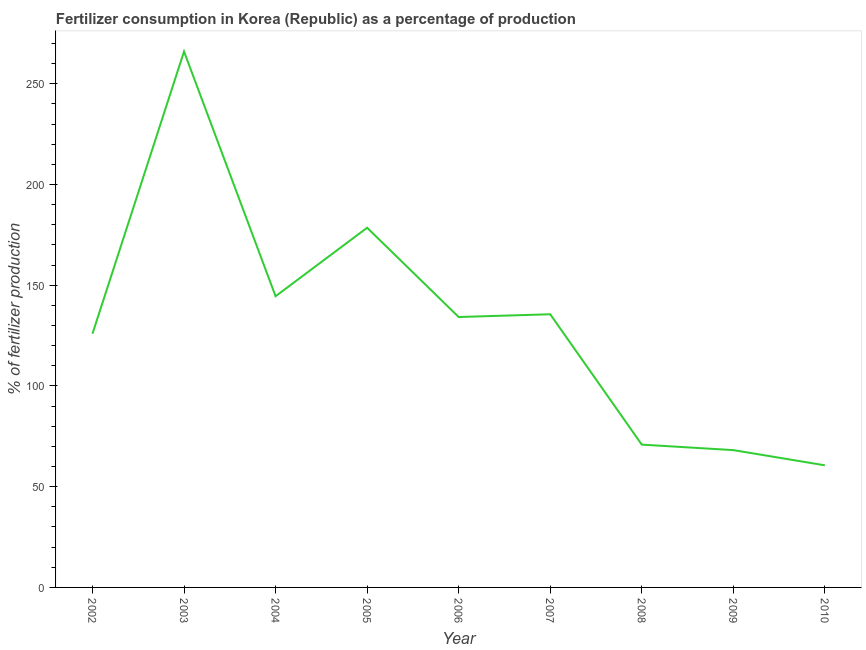What is the amount of fertilizer consumption in 2007?
Offer a terse response. 135.6. Across all years, what is the maximum amount of fertilizer consumption?
Offer a terse response. 266.02. Across all years, what is the minimum amount of fertilizer consumption?
Your answer should be compact. 60.61. What is the sum of the amount of fertilizer consumption?
Provide a succinct answer. 1184.54. What is the difference between the amount of fertilizer consumption in 2003 and 2010?
Provide a short and direct response. 205.41. What is the average amount of fertilizer consumption per year?
Make the answer very short. 131.62. What is the median amount of fertilizer consumption?
Offer a terse response. 134.23. Do a majority of the years between 2002 and 2007 (inclusive) have amount of fertilizer consumption greater than 260 %?
Keep it short and to the point. No. What is the ratio of the amount of fertilizer consumption in 2002 to that in 2009?
Keep it short and to the point. 1.85. Is the amount of fertilizer consumption in 2009 less than that in 2010?
Your response must be concise. No. Is the difference between the amount of fertilizer consumption in 2004 and 2007 greater than the difference between any two years?
Offer a terse response. No. What is the difference between the highest and the second highest amount of fertilizer consumption?
Provide a succinct answer. 87.48. What is the difference between the highest and the lowest amount of fertilizer consumption?
Your answer should be very brief. 205.41. Are the values on the major ticks of Y-axis written in scientific E-notation?
Provide a short and direct response. No. Does the graph contain any zero values?
Offer a terse response. No. Does the graph contain grids?
Give a very brief answer. No. What is the title of the graph?
Your answer should be compact. Fertilizer consumption in Korea (Republic) as a percentage of production. What is the label or title of the X-axis?
Your answer should be compact. Year. What is the label or title of the Y-axis?
Your answer should be very brief. % of fertilizer production. What is the % of fertilizer production in 2002?
Your response must be concise. 125.95. What is the % of fertilizer production in 2003?
Make the answer very short. 266.02. What is the % of fertilizer production of 2004?
Offer a terse response. 144.54. What is the % of fertilizer production of 2005?
Provide a short and direct response. 178.54. What is the % of fertilizer production in 2006?
Your answer should be very brief. 134.23. What is the % of fertilizer production in 2007?
Your response must be concise. 135.6. What is the % of fertilizer production in 2008?
Provide a short and direct response. 70.89. What is the % of fertilizer production of 2009?
Keep it short and to the point. 68.16. What is the % of fertilizer production in 2010?
Your response must be concise. 60.61. What is the difference between the % of fertilizer production in 2002 and 2003?
Your response must be concise. -140.07. What is the difference between the % of fertilizer production in 2002 and 2004?
Offer a terse response. -18.59. What is the difference between the % of fertilizer production in 2002 and 2005?
Your answer should be very brief. -52.59. What is the difference between the % of fertilizer production in 2002 and 2006?
Give a very brief answer. -8.28. What is the difference between the % of fertilizer production in 2002 and 2007?
Give a very brief answer. -9.65. What is the difference between the % of fertilizer production in 2002 and 2008?
Offer a terse response. 55.06. What is the difference between the % of fertilizer production in 2002 and 2009?
Give a very brief answer. 57.79. What is the difference between the % of fertilizer production in 2002 and 2010?
Offer a terse response. 65.34. What is the difference between the % of fertilizer production in 2003 and 2004?
Your response must be concise. 121.49. What is the difference between the % of fertilizer production in 2003 and 2005?
Provide a short and direct response. 87.48. What is the difference between the % of fertilizer production in 2003 and 2006?
Your response must be concise. 131.79. What is the difference between the % of fertilizer production in 2003 and 2007?
Make the answer very short. 130.42. What is the difference between the % of fertilizer production in 2003 and 2008?
Make the answer very short. 195.13. What is the difference between the % of fertilizer production in 2003 and 2009?
Offer a very short reply. 197.86. What is the difference between the % of fertilizer production in 2003 and 2010?
Provide a short and direct response. 205.41. What is the difference between the % of fertilizer production in 2004 and 2005?
Offer a very short reply. -34.01. What is the difference between the % of fertilizer production in 2004 and 2006?
Your response must be concise. 10.3. What is the difference between the % of fertilizer production in 2004 and 2007?
Make the answer very short. 8.94. What is the difference between the % of fertilizer production in 2004 and 2008?
Provide a short and direct response. 73.65. What is the difference between the % of fertilizer production in 2004 and 2009?
Give a very brief answer. 76.38. What is the difference between the % of fertilizer production in 2004 and 2010?
Your answer should be compact. 83.93. What is the difference between the % of fertilizer production in 2005 and 2006?
Your answer should be compact. 44.31. What is the difference between the % of fertilizer production in 2005 and 2007?
Your response must be concise. 42.95. What is the difference between the % of fertilizer production in 2005 and 2008?
Your answer should be compact. 107.65. What is the difference between the % of fertilizer production in 2005 and 2009?
Ensure brevity in your answer.  110.38. What is the difference between the % of fertilizer production in 2005 and 2010?
Keep it short and to the point. 117.93. What is the difference between the % of fertilizer production in 2006 and 2007?
Make the answer very short. -1.36. What is the difference between the % of fertilizer production in 2006 and 2008?
Your answer should be compact. 63.34. What is the difference between the % of fertilizer production in 2006 and 2009?
Offer a terse response. 66.07. What is the difference between the % of fertilizer production in 2006 and 2010?
Provide a succinct answer. 73.62. What is the difference between the % of fertilizer production in 2007 and 2008?
Ensure brevity in your answer.  64.71. What is the difference between the % of fertilizer production in 2007 and 2009?
Provide a succinct answer. 67.44. What is the difference between the % of fertilizer production in 2007 and 2010?
Your answer should be very brief. 74.99. What is the difference between the % of fertilizer production in 2008 and 2009?
Your answer should be compact. 2.73. What is the difference between the % of fertilizer production in 2008 and 2010?
Your response must be concise. 10.28. What is the difference between the % of fertilizer production in 2009 and 2010?
Make the answer very short. 7.55. What is the ratio of the % of fertilizer production in 2002 to that in 2003?
Ensure brevity in your answer.  0.47. What is the ratio of the % of fertilizer production in 2002 to that in 2004?
Your response must be concise. 0.87. What is the ratio of the % of fertilizer production in 2002 to that in 2005?
Ensure brevity in your answer.  0.7. What is the ratio of the % of fertilizer production in 2002 to that in 2006?
Your answer should be compact. 0.94. What is the ratio of the % of fertilizer production in 2002 to that in 2007?
Ensure brevity in your answer.  0.93. What is the ratio of the % of fertilizer production in 2002 to that in 2008?
Your answer should be very brief. 1.78. What is the ratio of the % of fertilizer production in 2002 to that in 2009?
Your answer should be compact. 1.85. What is the ratio of the % of fertilizer production in 2002 to that in 2010?
Ensure brevity in your answer.  2.08. What is the ratio of the % of fertilizer production in 2003 to that in 2004?
Make the answer very short. 1.84. What is the ratio of the % of fertilizer production in 2003 to that in 2005?
Keep it short and to the point. 1.49. What is the ratio of the % of fertilizer production in 2003 to that in 2006?
Provide a succinct answer. 1.98. What is the ratio of the % of fertilizer production in 2003 to that in 2007?
Your answer should be very brief. 1.96. What is the ratio of the % of fertilizer production in 2003 to that in 2008?
Provide a short and direct response. 3.75. What is the ratio of the % of fertilizer production in 2003 to that in 2009?
Provide a short and direct response. 3.9. What is the ratio of the % of fertilizer production in 2003 to that in 2010?
Provide a short and direct response. 4.39. What is the ratio of the % of fertilizer production in 2004 to that in 2005?
Ensure brevity in your answer.  0.81. What is the ratio of the % of fertilizer production in 2004 to that in 2006?
Your answer should be very brief. 1.08. What is the ratio of the % of fertilizer production in 2004 to that in 2007?
Provide a succinct answer. 1.07. What is the ratio of the % of fertilizer production in 2004 to that in 2008?
Offer a very short reply. 2.04. What is the ratio of the % of fertilizer production in 2004 to that in 2009?
Ensure brevity in your answer.  2.12. What is the ratio of the % of fertilizer production in 2004 to that in 2010?
Give a very brief answer. 2.38. What is the ratio of the % of fertilizer production in 2005 to that in 2006?
Offer a very short reply. 1.33. What is the ratio of the % of fertilizer production in 2005 to that in 2007?
Ensure brevity in your answer.  1.32. What is the ratio of the % of fertilizer production in 2005 to that in 2008?
Keep it short and to the point. 2.52. What is the ratio of the % of fertilizer production in 2005 to that in 2009?
Provide a succinct answer. 2.62. What is the ratio of the % of fertilizer production in 2005 to that in 2010?
Your answer should be compact. 2.95. What is the ratio of the % of fertilizer production in 2006 to that in 2007?
Offer a very short reply. 0.99. What is the ratio of the % of fertilizer production in 2006 to that in 2008?
Offer a very short reply. 1.89. What is the ratio of the % of fertilizer production in 2006 to that in 2009?
Ensure brevity in your answer.  1.97. What is the ratio of the % of fertilizer production in 2006 to that in 2010?
Ensure brevity in your answer.  2.21. What is the ratio of the % of fertilizer production in 2007 to that in 2008?
Provide a short and direct response. 1.91. What is the ratio of the % of fertilizer production in 2007 to that in 2009?
Offer a very short reply. 1.99. What is the ratio of the % of fertilizer production in 2007 to that in 2010?
Provide a short and direct response. 2.24. What is the ratio of the % of fertilizer production in 2008 to that in 2009?
Your response must be concise. 1.04. What is the ratio of the % of fertilizer production in 2008 to that in 2010?
Your response must be concise. 1.17. 